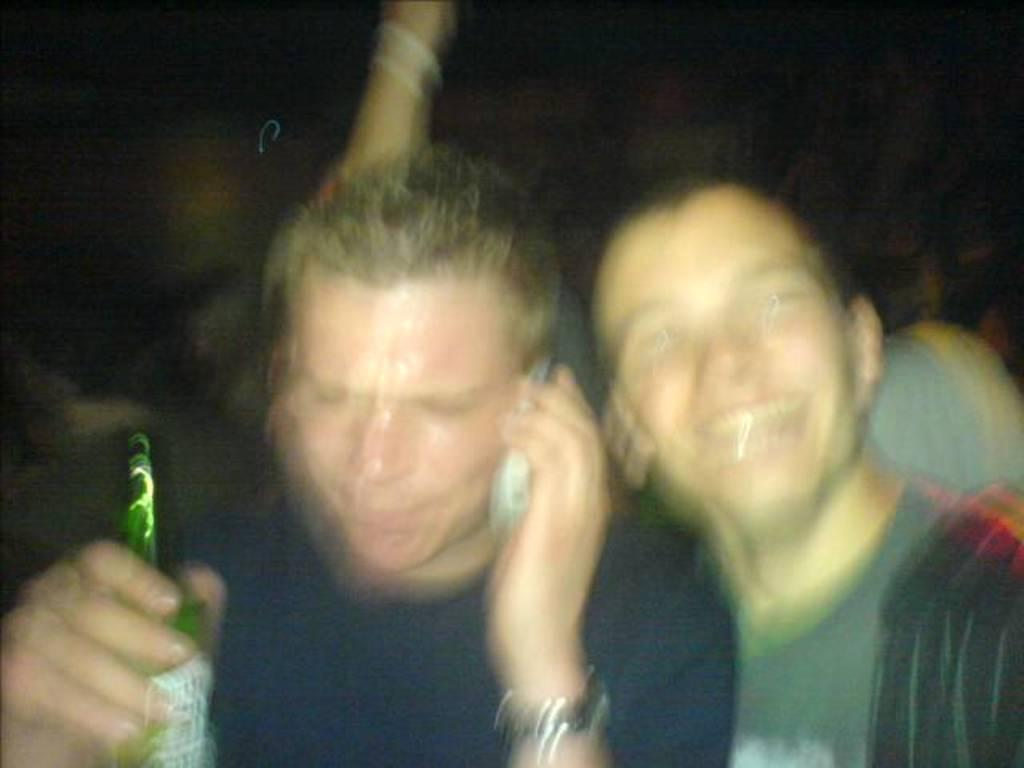What is the man in the image holding? The man is holding a beer bottle. What is the man doing with the microphone? The man is talking on a microphone. How many people are in the image? There are two people in the image. What is the expression of the second man? The second man is smiling. Can you see any cheese in the image? There is no cheese present in the image. Is the man talking on the microphone in space? The image does not provide any information about the location being in space, and there is no indication of space in the image. 